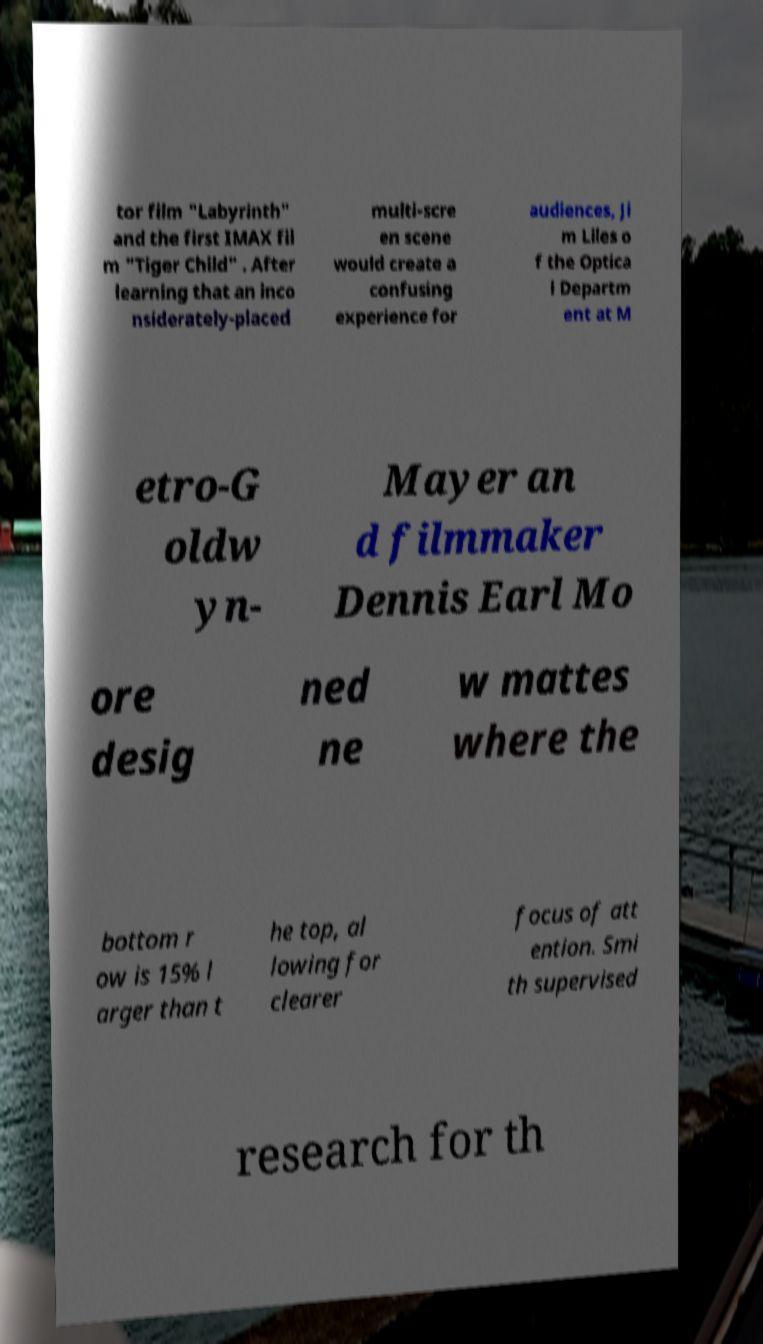Can you read and provide the text displayed in the image?This photo seems to have some interesting text. Can you extract and type it out for me? tor film "Labyrinth" and the first IMAX fil m "Tiger Child" . After learning that an inco nsiderately-placed multi-scre en scene would create a confusing experience for audiences, Ji m Liles o f the Optica l Departm ent at M etro-G oldw yn- Mayer an d filmmaker Dennis Earl Mo ore desig ned ne w mattes where the bottom r ow is 15% l arger than t he top, al lowing for clearer focus of att ention. Smi th supervised research for th 